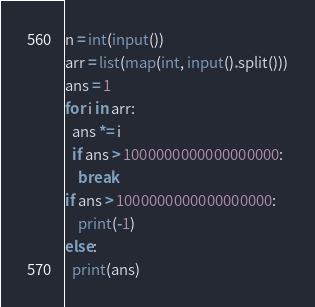Convert code to text. <code><loc_0><loc_0><loc_500><loc_500><_Python_>n = int(input())
arr = list(map(int, input().split()))
ans = 1
for i in arr:
  ans *= i
  if ans > 1000000000000000000:
    break
if ans > 1000000000000000000:
	print(-1)
else:
  print(ans)</code> 